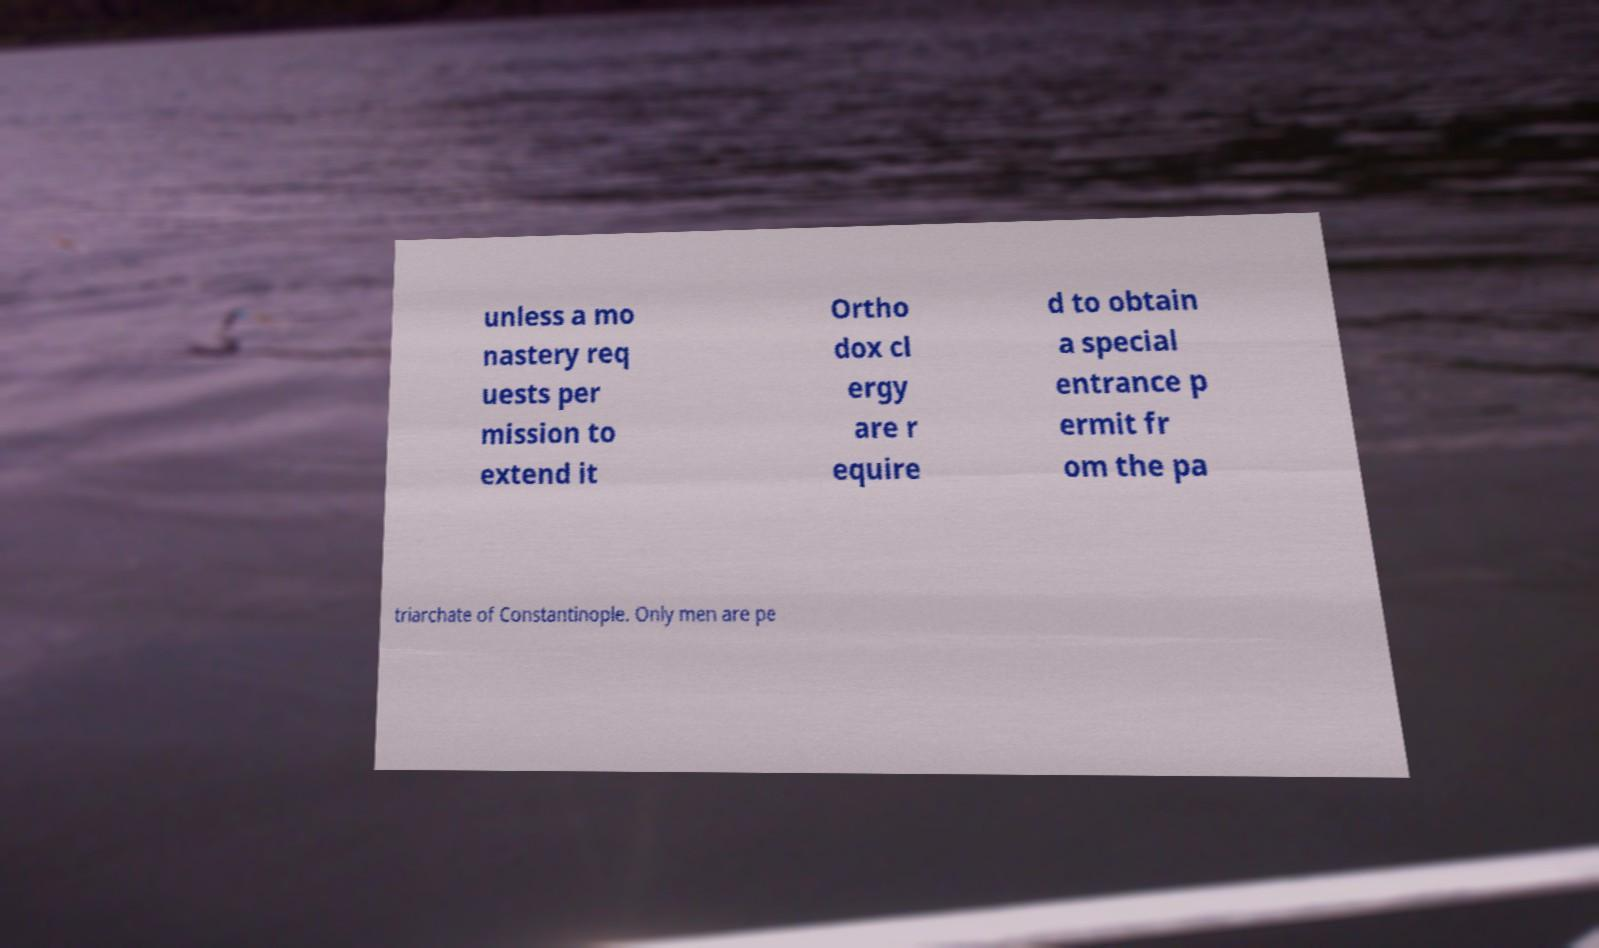I need the written content from this picture converted into text. Can you do that? unless a mo nastery req uests per mission to extend it Ortho dox cl ergy are r equire d to obtain a special entrance p ermit fr om the pa triarchate of Constantinople. Only men are pe 